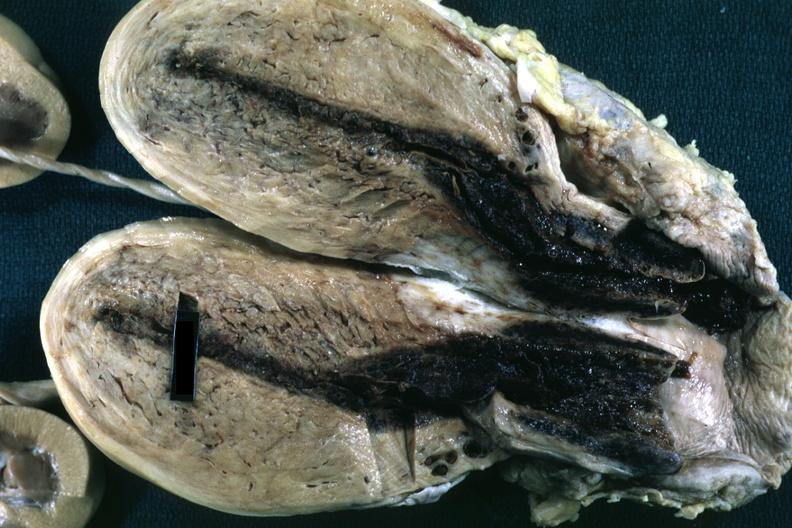s female reproductive present?
Answer the question using a single word or phrase. Yes 